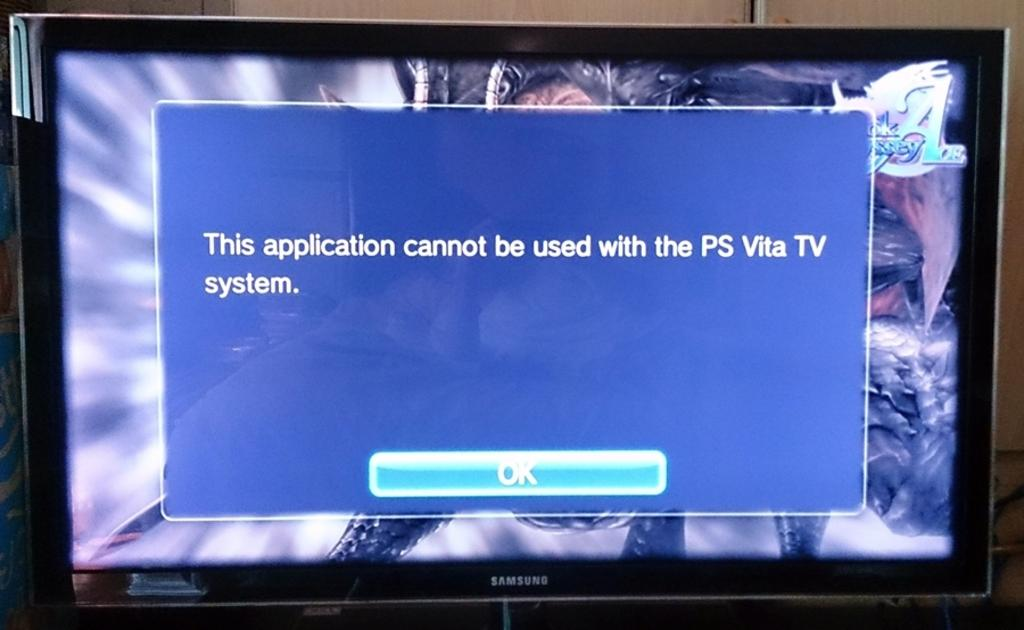<image>
Create a compact narrative representing the image presented. A Samsung TV with an error message on the screen. 